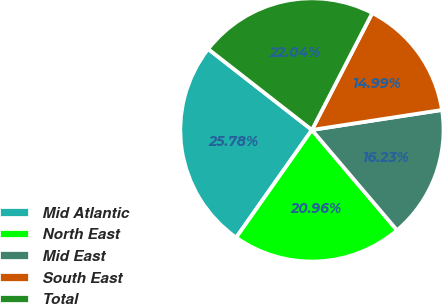Convert chart. <chart><loc_0><loc_0><loc_500><loc_500><pie_chart><fcel>Mid Atlantic<fcel>North East<fcel>Mid East<fcel>South East<fcel>Total<nl><fcel>25.78%<fcel>20.96%<fcel>16.23%<fcel>14.99%<fcel>22.04%<nl></chart> 